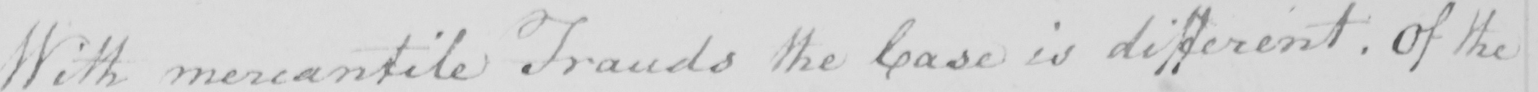What does this handwritten line say? With mercantile Frauds the Case is different . Of the 